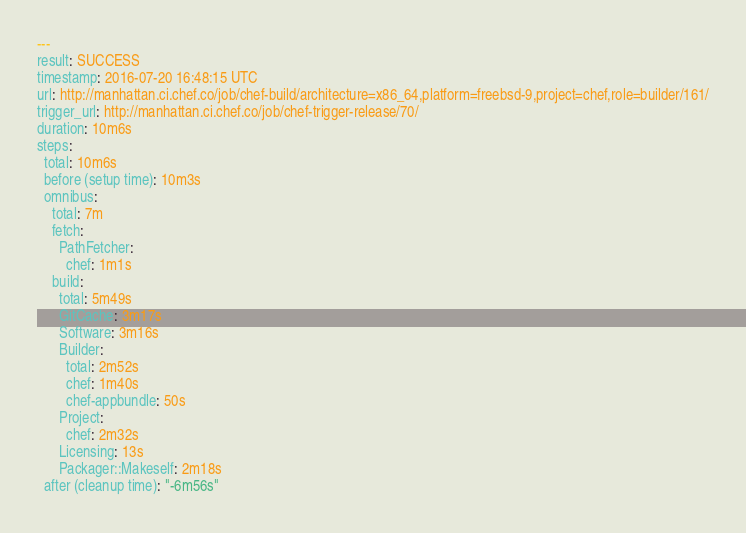<code> <loc_0><loc_0><loc_500><loc_500><_YAML_>---
result: SUCCESS
timestamp: 2016-07-20 16:48:15 UTC
url: http://manhattan.ci.chef.co/job/chef-build/architecture=x86_64,platform=freebsd-9,project=chef,role=builder/161/
trigger_url: http://manhattan.ci.chef.co/job/chef-trigger-release/70/
duration: 10m6s
steps:
  total: 10m6s
  before (setup time): 10m3s
  omnibus:
    total: 7m
    fetch:
      PathFetcher:
        chef: 1m1s
    build:
      total: 5m49s
      GitCache: 3m17s
      Software: 3m16s
      Builder:
        total: 2m52s
        chef: 1m40s
        chef-appbundle: 50s
      Project:
        chef: 2m32s
      Licensing: 13s
      Packager::Makeself: 2m18s
  after (cleanup time): "-6m56s"
</code> 